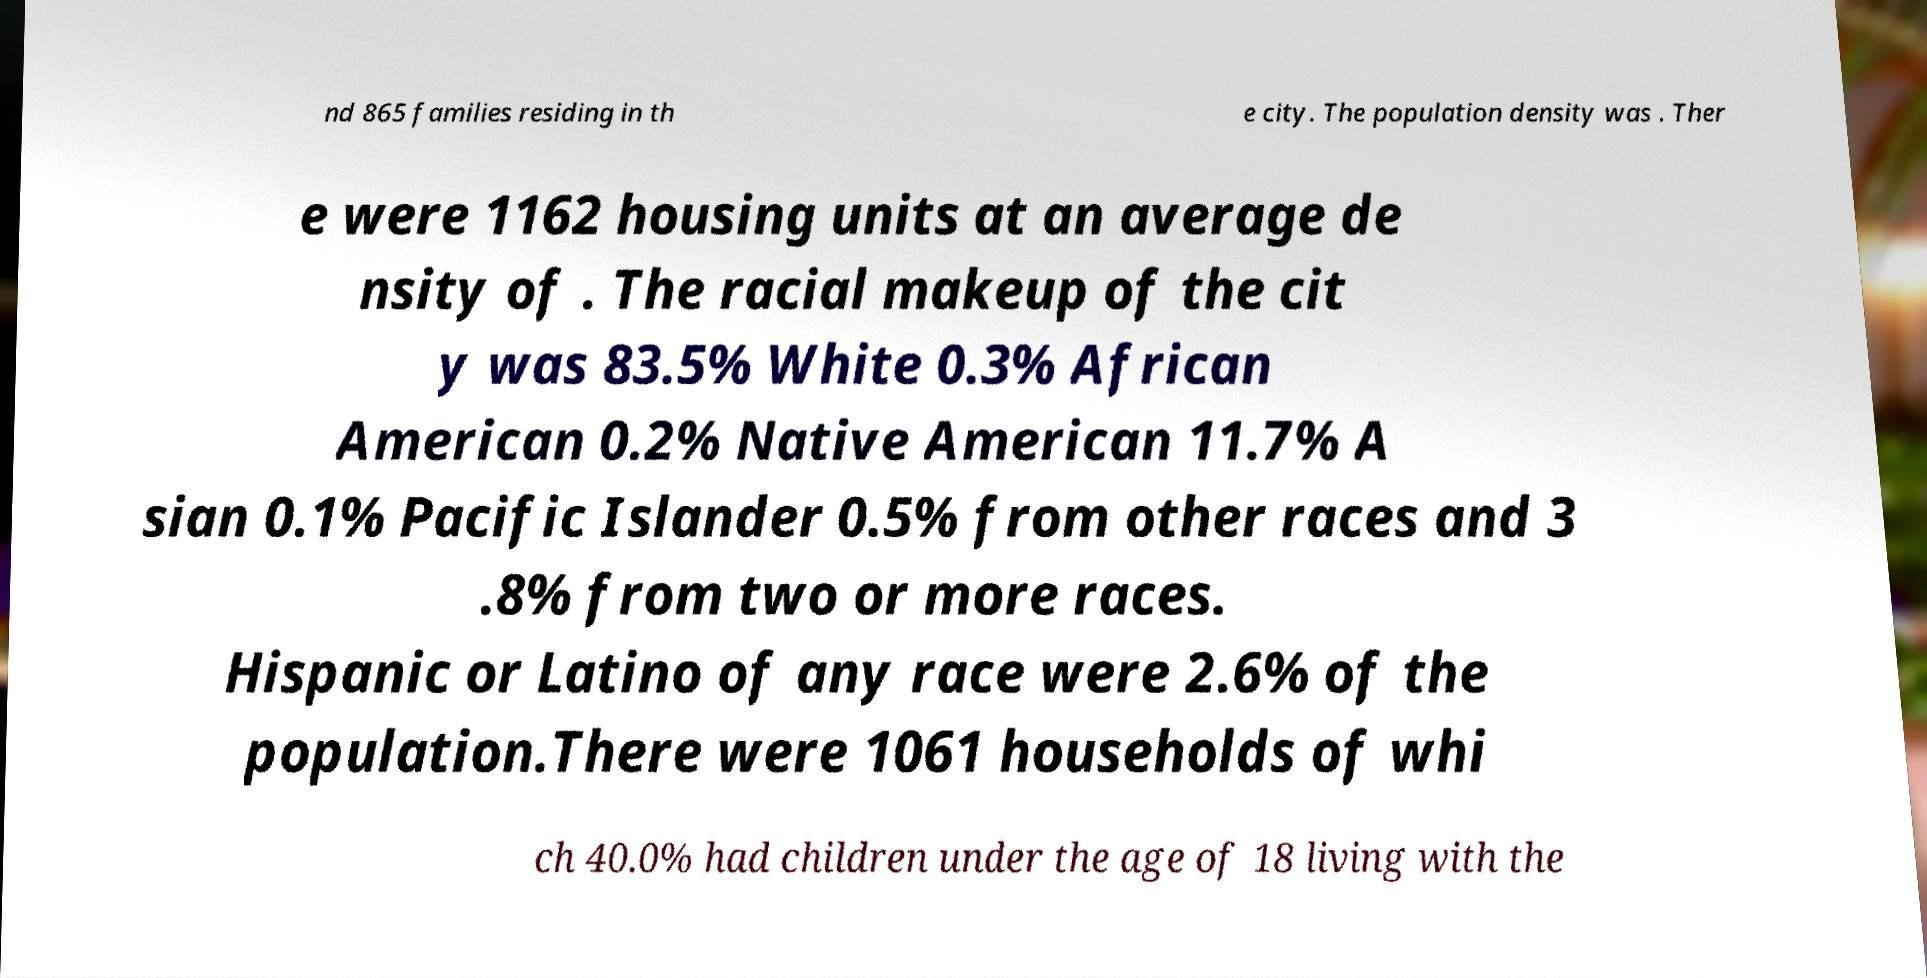There's text embedded in this image that I need extracted. Can you transcribe it verbatim? nd 865 families residing in th e city. The population density was . Ther e were 1162 housing units at an average de nsity of . The racial makeup of the cit y was 83.5% White 0.3% African American 0.2% Native American 11.7% A sian 0.1% Pacific Islander 0.5% from other races and 3 .8% from two or more races. Hispanic or Latino of any race were 2.6% of the population.There were 1061 households of whi ch 40.0% had children under the age of 18 living with the 